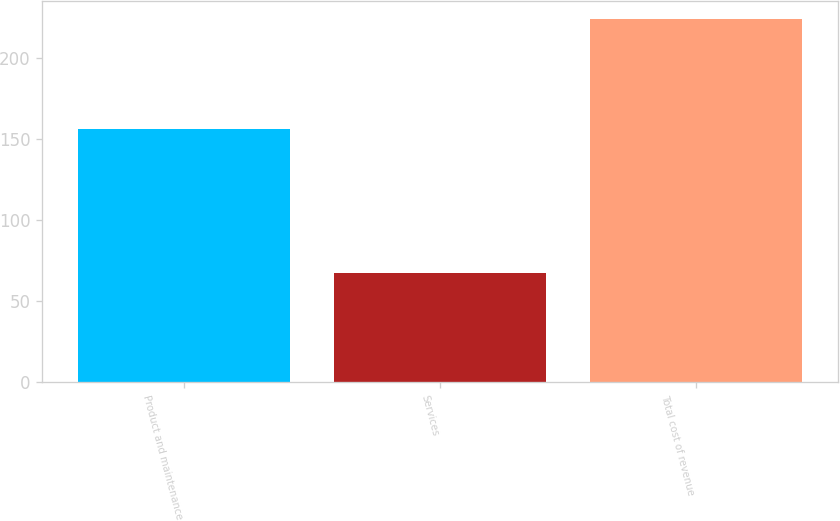<chart> <loc_0><loc_0><loc_500><loc_500><bar_chart><fcel>Product and maintenance<fcel>Services<fcel>Total cost of revenue<nl><fcel>156.3<fcel>67.4<fcel>223.7<nl></chart> 